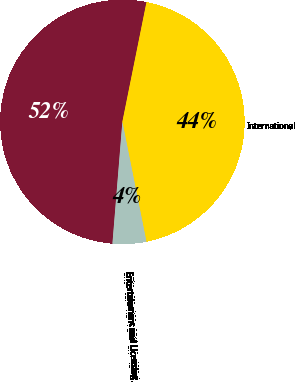Convert chart to OTSL. <chart><loc_0><loc_0><loc_500><loc_500><pie_chart><fcel>US and Canada<fcel>International<fcel>Entertainment and Licensing<nl><fcel>51.87%<fcel>43.68%<fcel>4.45%<nl></chart> 